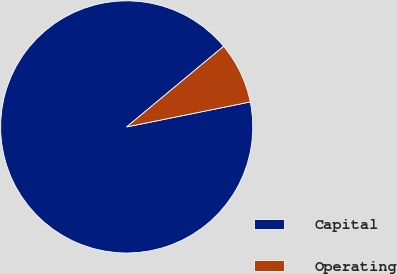<chart> <loc_0><loc_0><loc_500><loc_500><pie_chart><fcel>Capital<fcel>Operating<nl><fcel>92.13%<fcel>7.87%<nl></chart> 